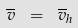Convert formula to latex. <formula><loc_0><loc_0><loc_500><loc_500>\overline { v } \ = \ \overline { v } _ { h }</formula> 